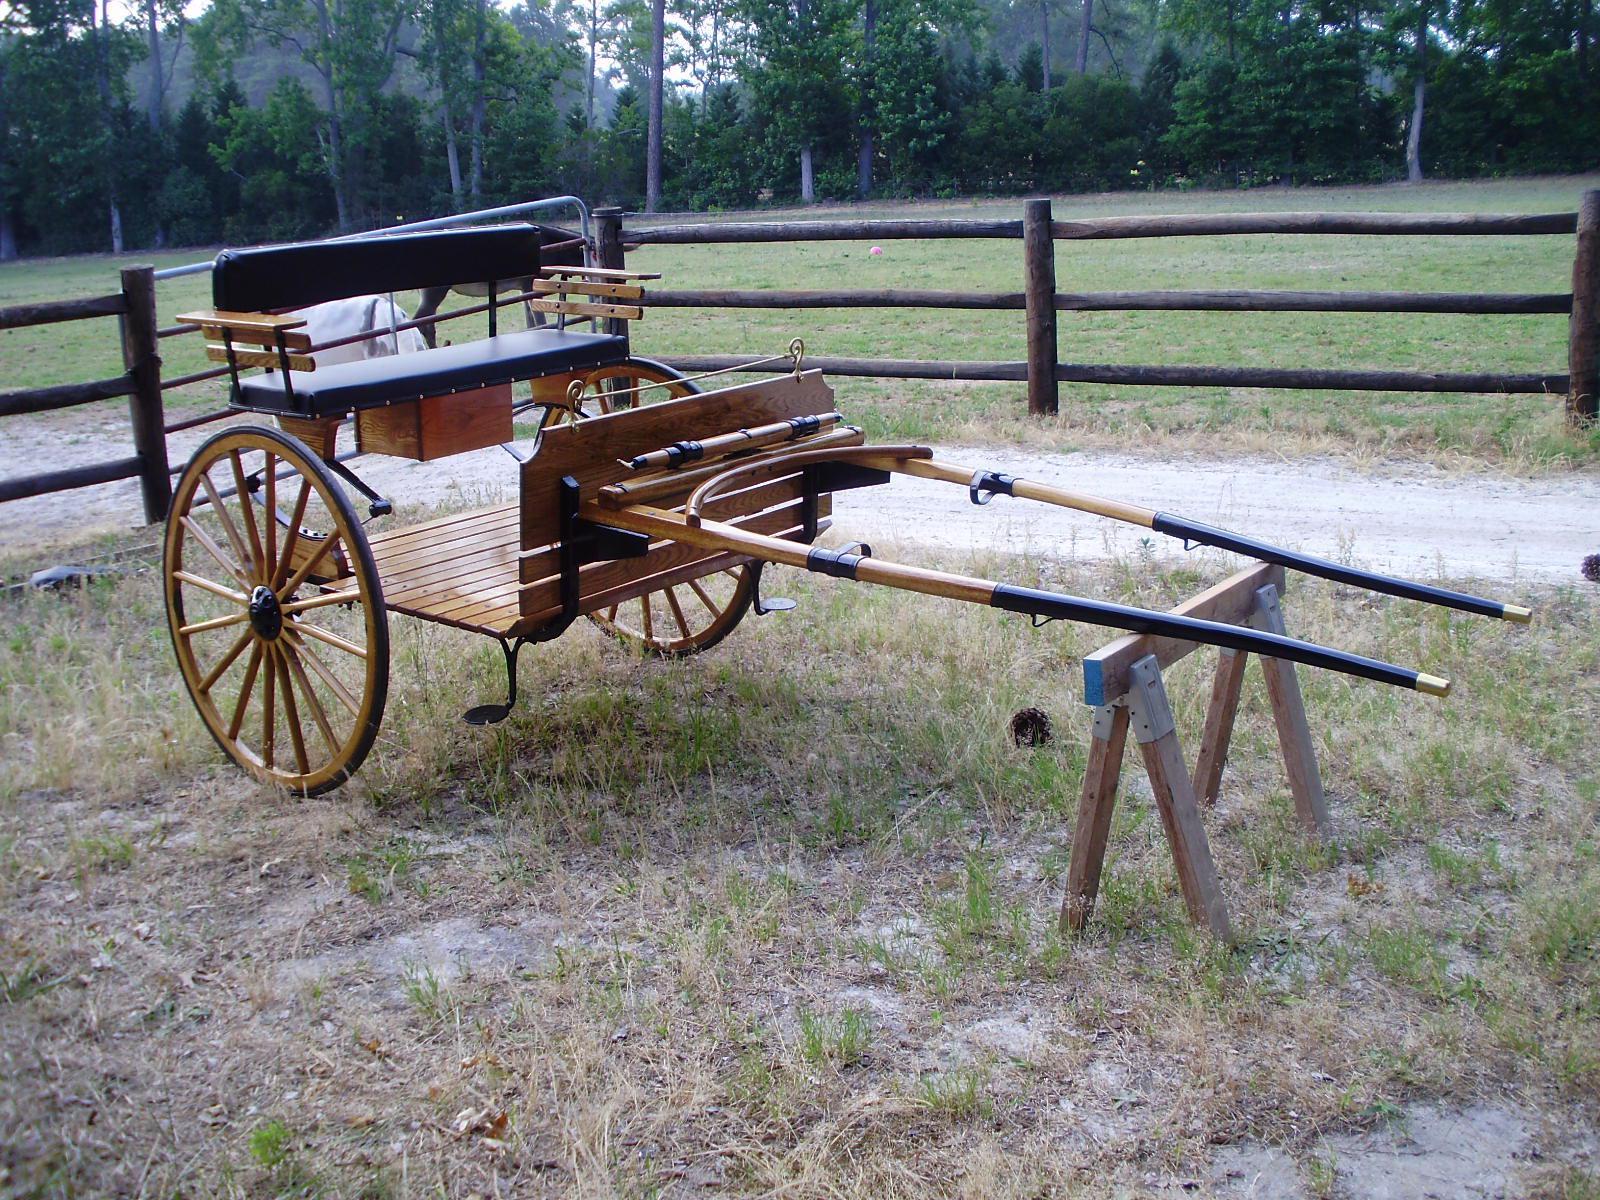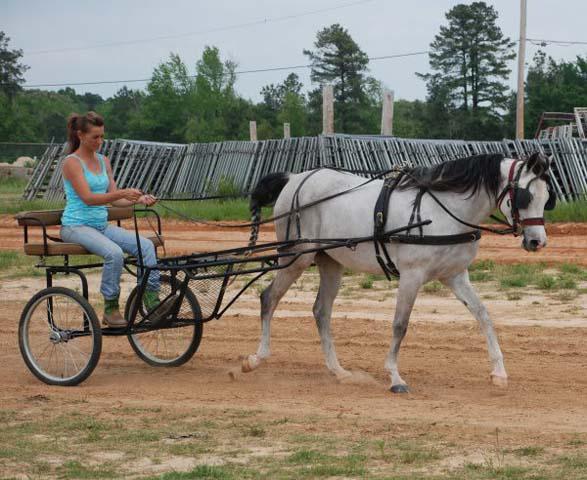The first image is the image on the left, the second image is the image on the right. Assess this claim about the two images: "The foot rest of the buggy in the left photo is made from wooden slats.". Correct or not? Answer yes or no. Yes. 